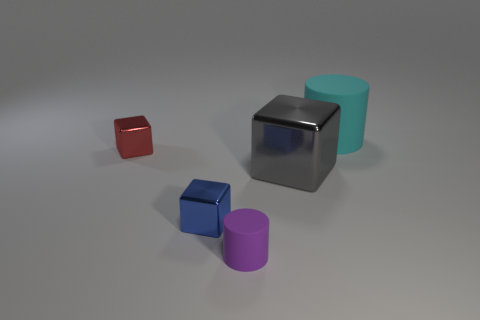What material is the large thing that is behind the small shiny object on the left side of the small blue block made of?
Ensure brevity in your answer.  Rubber. What number of objects are large metal blocks or matte cylinders in front of the cyan rubber thing?
Offer a terse response. 2. There is a blue object that is the same material as the red thing; what size is it?
Make the answer very short. Small. What number of blue objects are blocks or large matte things?
Provide a short and direct response. 1. There is a big matte thing that is right of the red object; is it the same shape as the metal object that is to the right of the tiny rubber thing?
Ensure brevity in your answer.  No. How many large brown balls are there?
Your answer should be very brief. 0. What is the shape of the thing that is the same material as the cyan cylinder?
Your response must be concise. Cylinder. Are there any other things that have the same color as the large shiny object?
Offer a very short reply. No. There is a big cylinder; does it have the same color as the block behind the big metal object?
Your answer should be very brief. No. Are there fewer blue metal things on the right side of the big cube than big cyan matte things?
Your answer should be compact. Yes. 